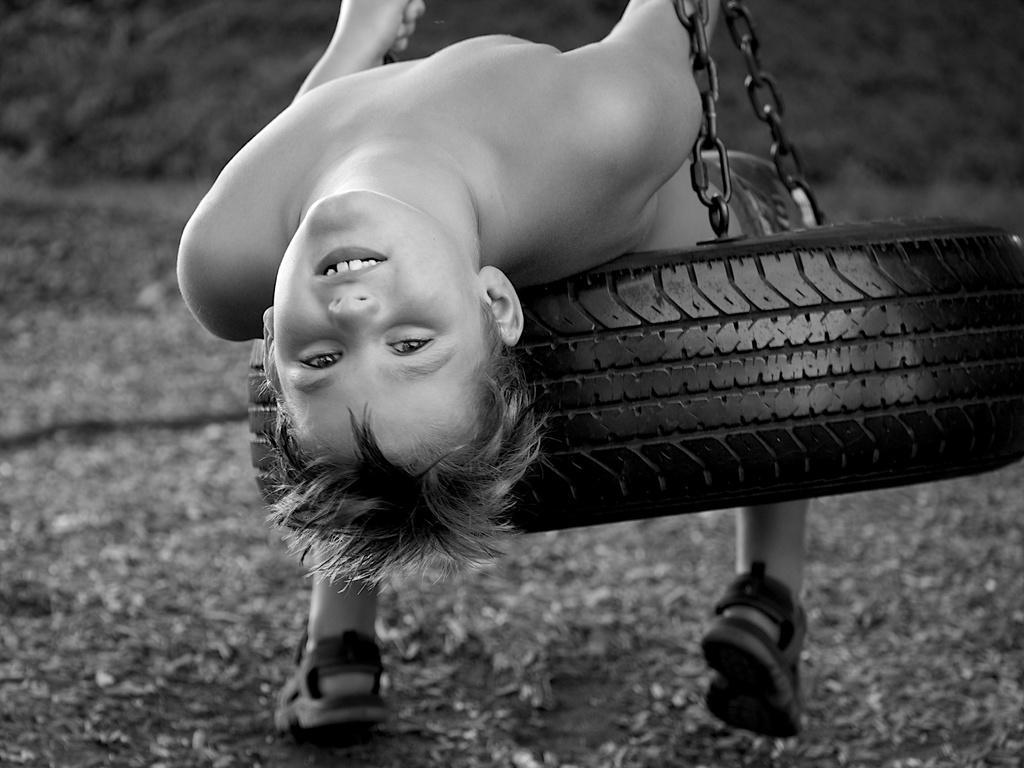In one or two sentences, can you explain what this image depicts? Here in this picture we can see a tire hanging in air with the help of chains and on that we can see a child lying and swinging and we can see grass present on the ground in blurry manner. 